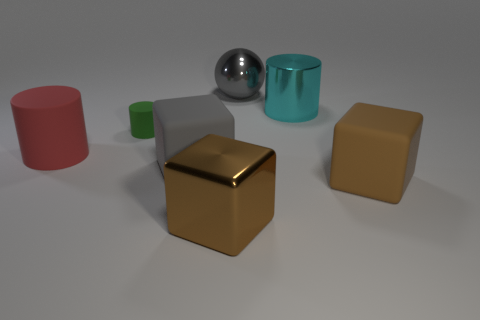Add 2 big red things. How many objects exist? 9 Subtract all blocks. How many objects are left? 4 Add 6 big brown blocks. How many big brown blocks exist? 8 Subtract 0 blue cubes. How many objects are left? 7 Subtract all big rubber things. Subtract all big brown cubes. How many objects are left? 2 Add 1 red cylinders. How many red cylinders are left? 2 